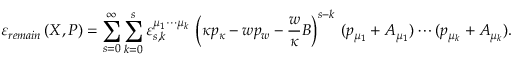<formula> <loc_0><loc_0><loc_500><loc_500>\varepsilon _ { r e m a i n } \left ( X , P \right ) = \sum _ { s = 0 } ^ { \infty } \sum _ { k = 0 } ^ { s } \varepsilon _ { s , k } ^ { \mu _ { 1 } \cdots \mu _ { k } } \, \left ( \kappa p _ { \kappa } - w p _ { w } - \frac { w } { \kappa } B \right ) ^ { s - k } \, ( p _ { \mu _ { 1 } } + A _ { \mu _ { 1 } } ) \cdots ( p _ { \mu _ { k } } + A _ { \mu _ { k } } ) .</formula> 